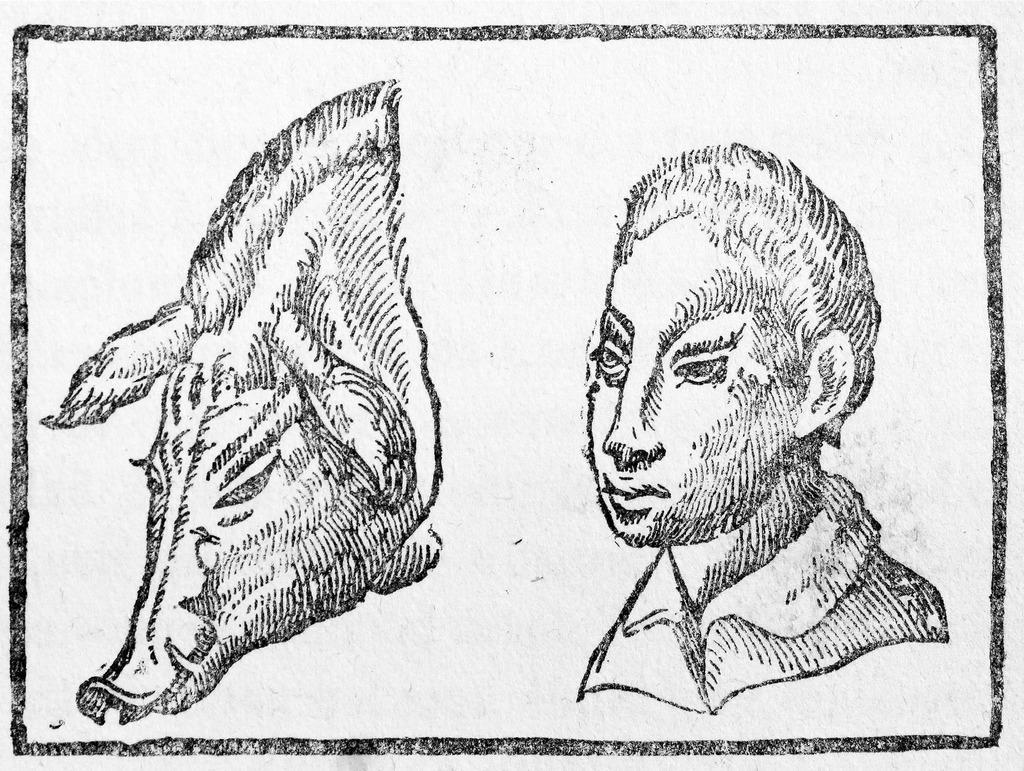In one or two sentences, can you explain what this image depicts? In this image we can see an art of an animal and a person on the white color surface. 